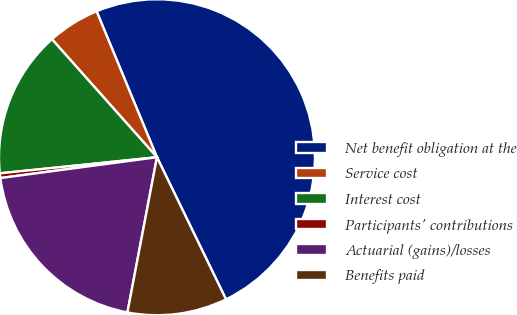Convert chart. <chart><loc_0><loc_0><loc_500><loc_500><pie_chart><fcel>Net benefit obligation at the<fcel>Service cost<fcel>Interest cost<fcel>Participants' contributions<fcel>Actuarial (gains)/losses<fcel>Benefits paid<nl><fcel>49.04%<fcel>5.33%<fcel>15.05%<fcel>0.48%<fcel>19.9%<fcel>10.19%<nl></chart> 